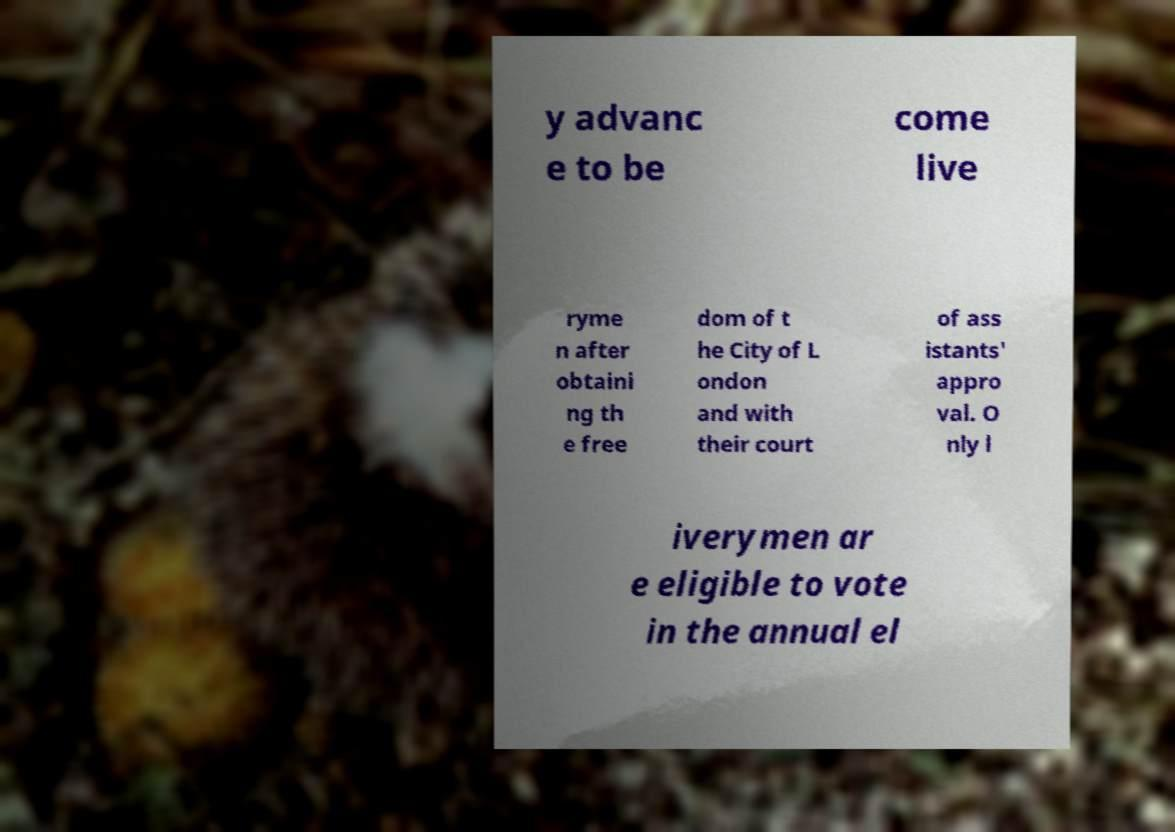Please read and relay the text visible in this image. What does it say? y advanc e to be come live ryme n after obtaini ng th e free dom of t he City of L ondon and with their court of ass istants' appro val. O nly l iverymen ar e eligible to vote in the annual el 